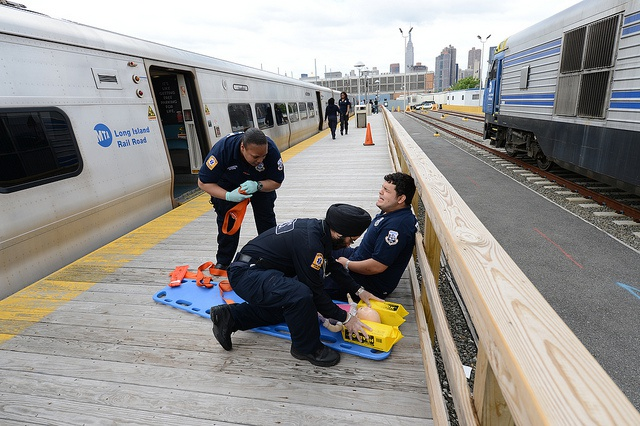Describe the objects in this image and their specific colors. I can see train in gray, darkgray, black, and lightgray tones, train in gray, black, darkgray, and lightgray tones, people in gray, black, and navy tones, people in gray, black, and maroon tones, and people in gray, black, navy, and lightgray tones in this image. 